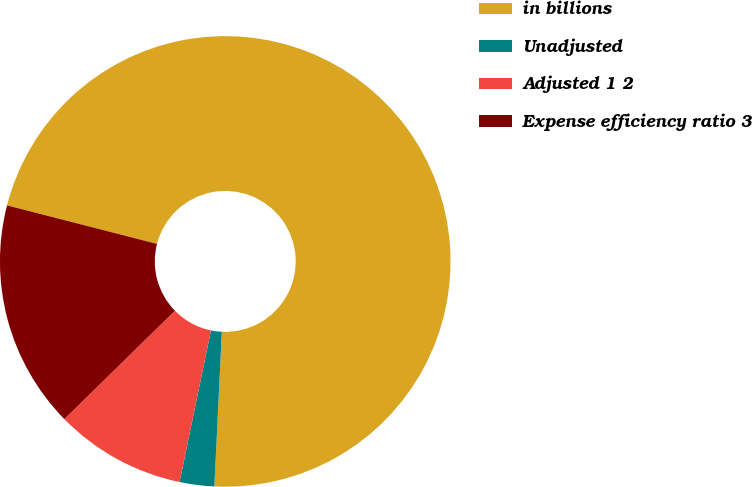Convert chart. <chart><loc_0><loc_0><loc_500><loc_500><pie_chart><fcel>in billions<fcel>Unadjusted<fcel>Adjusted 1 2<fcel>Expense efficiency ratio 3<nl><fcel>71.77%<fcel>2.48%<fcel>9.41%<fcel>16.34%<nl></chart> 